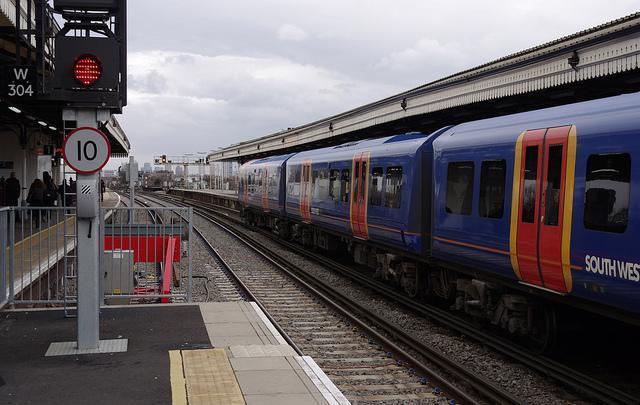How many train cars can be seen?
Give a very brief answer. 3. 